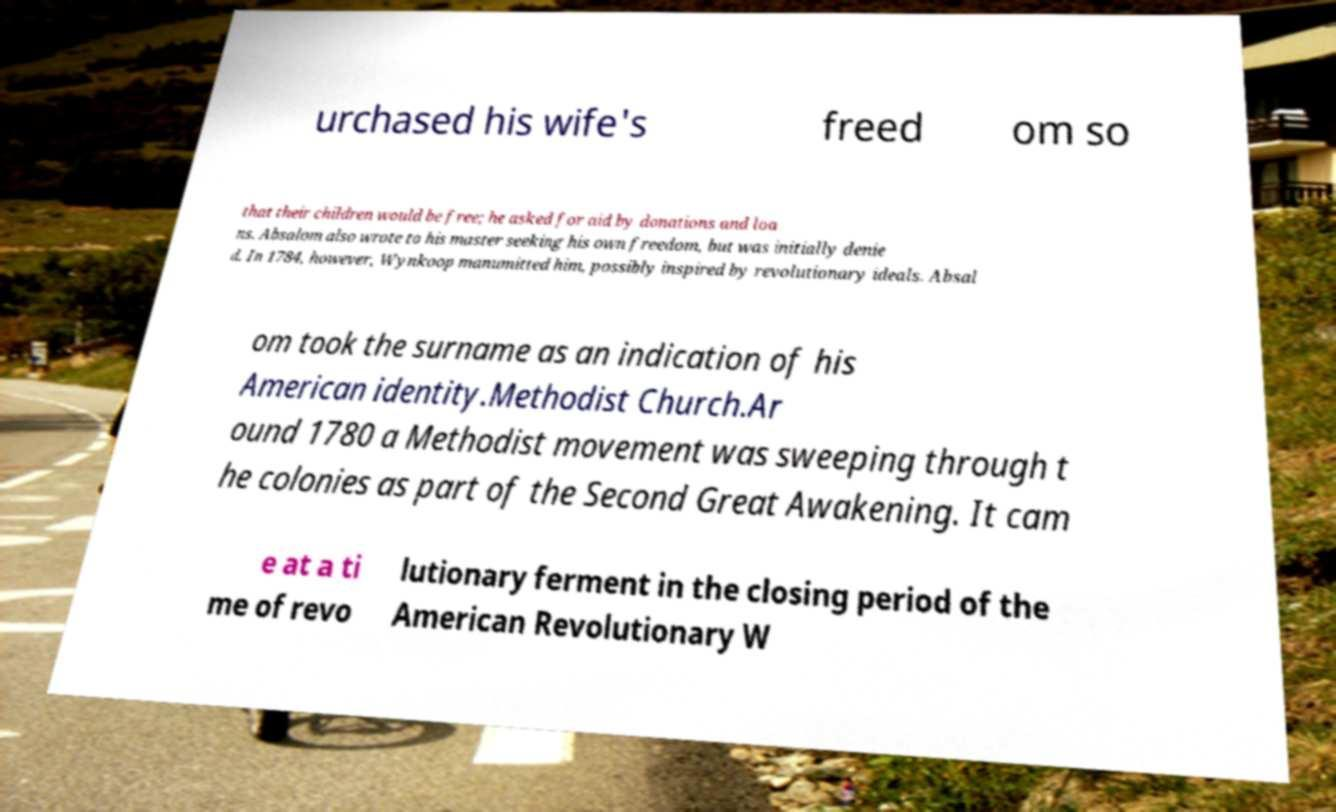Could you assist in decoding the text presented in this image and type it out clearly? urchased his wife's freed om so that their children would be free; he asked for aid by donations and loa ns. Absalom also wrote to his master seeking his own freedom, but was initially denie d. In 1784, however, Wynkoop manumitted him, possibly inspired by revolutionary ideals. Absal om took the surname as an indication of his American identity.Methodist Church.Ar ound 1780 a Methodist movement was sweeping through t he colonies as part of the Second Great Awakening. It cam e at a ti me of revo lutionary ferment in the closing period of the American Revolutionary W 